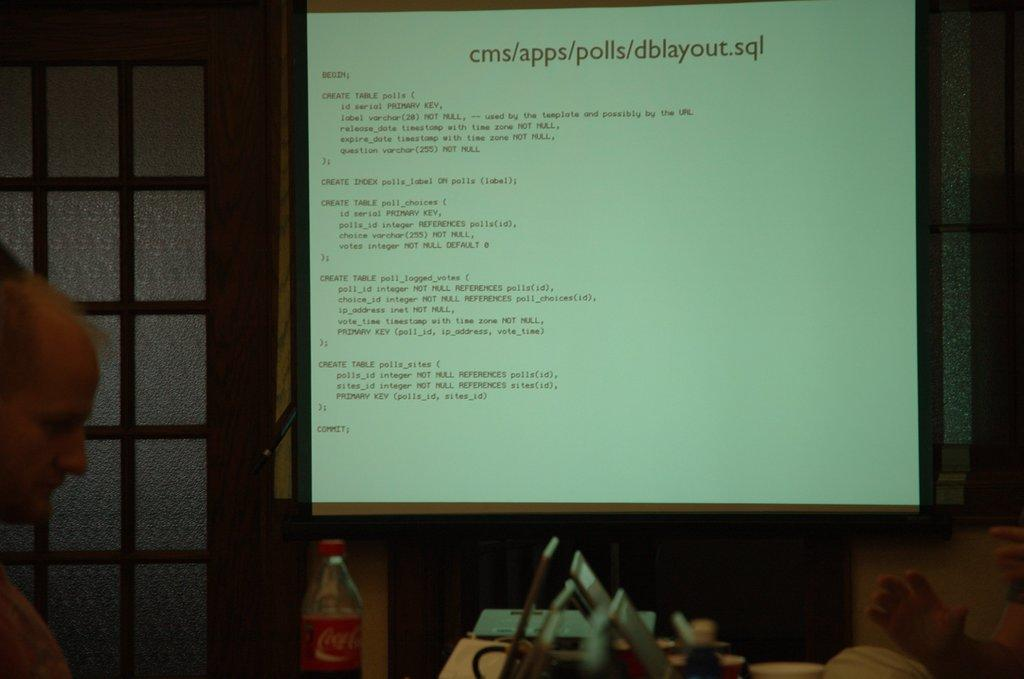<image>
Summarize the visual content of the image. A projector screen with a man standing perpendicular to it shows computer commands with the second command saying CREATE TABLE. 